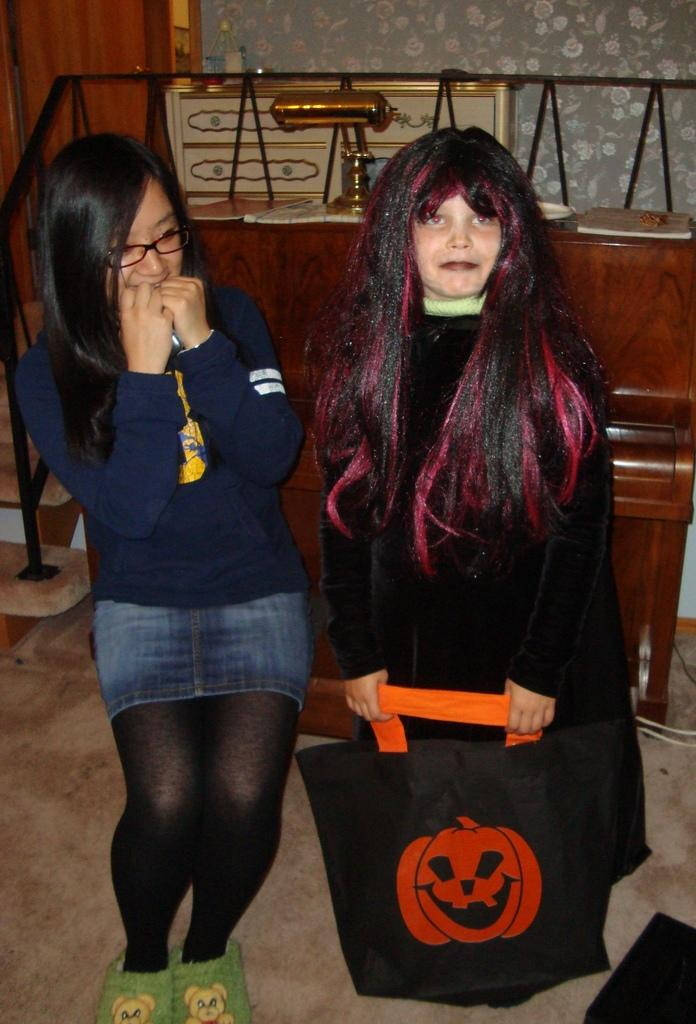How many girls are in the image? There are two girls in the image. Where is the girl on the right side located? The girl on the right side is on the right side of the image. What is the girl on the right side holding? The girl on the right side is holding a bag. What color is the dress worn by the girl on the right side? The girl on the right side is wearing a black color dress. What type of furniture is present in the image? There is a table in the image. What type of structure is visible in the background? There is a wall in the image. What type of loaf is the girl on the left side eating in the image? There is no loaf present in the image, and the girl on the left side is not eating anything. 